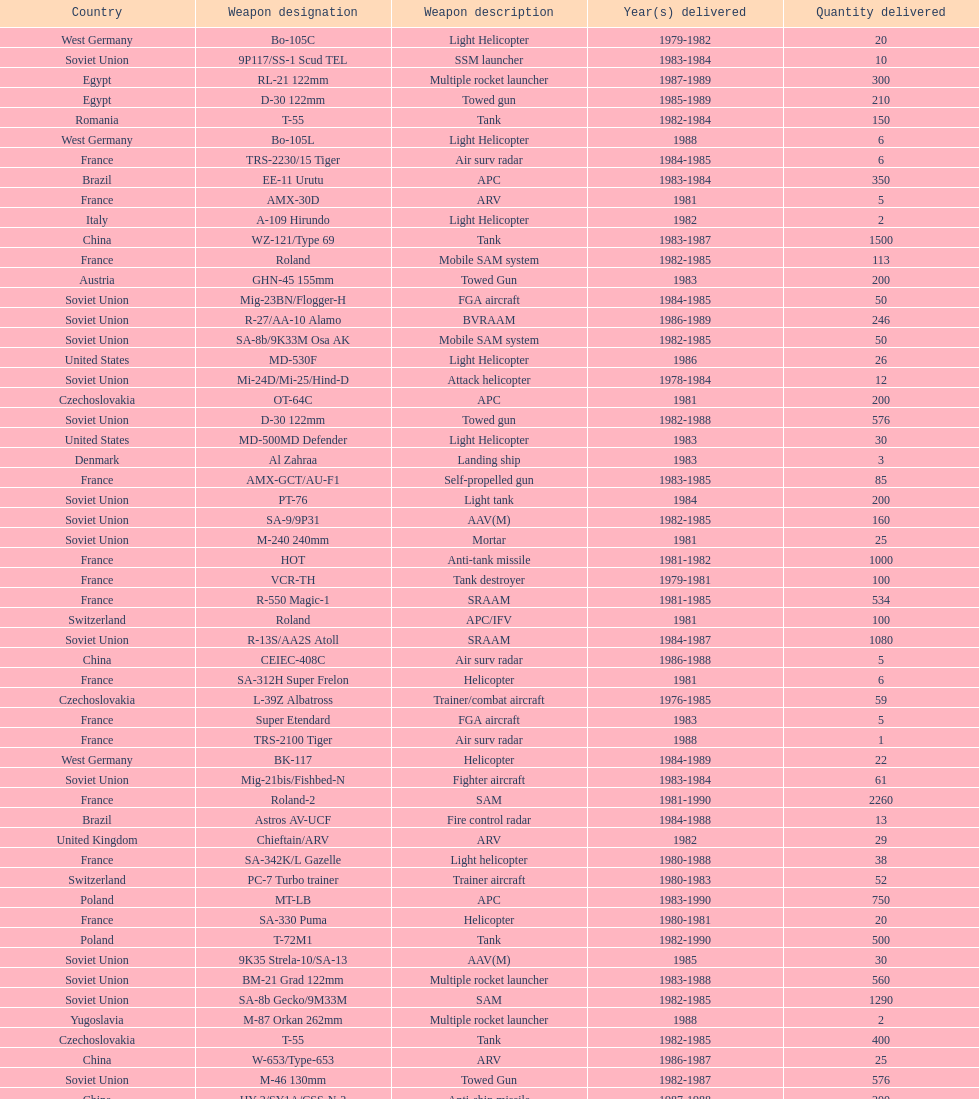Which was the first country to sell weapons to iraq? Czechoslovakia. 